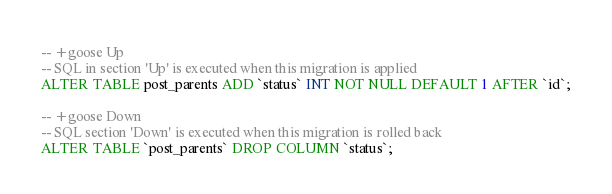Convert code to text. <code><loc_0><loc_0><loc_500><loc_500><_SQL_>
-- +goose Up
-- SQL in section 'Up' is executed when this migration is applied
ALTER TABLE post_parents ADD `status` INT NOT NULL DEFAULT 1 AFTER `id`;

-- +goose Down
-- SQL section 'Down' is executed when this migration is rolled back
ALTER TABLE `post_parents` DROP COLUMN `status`;
</code> 